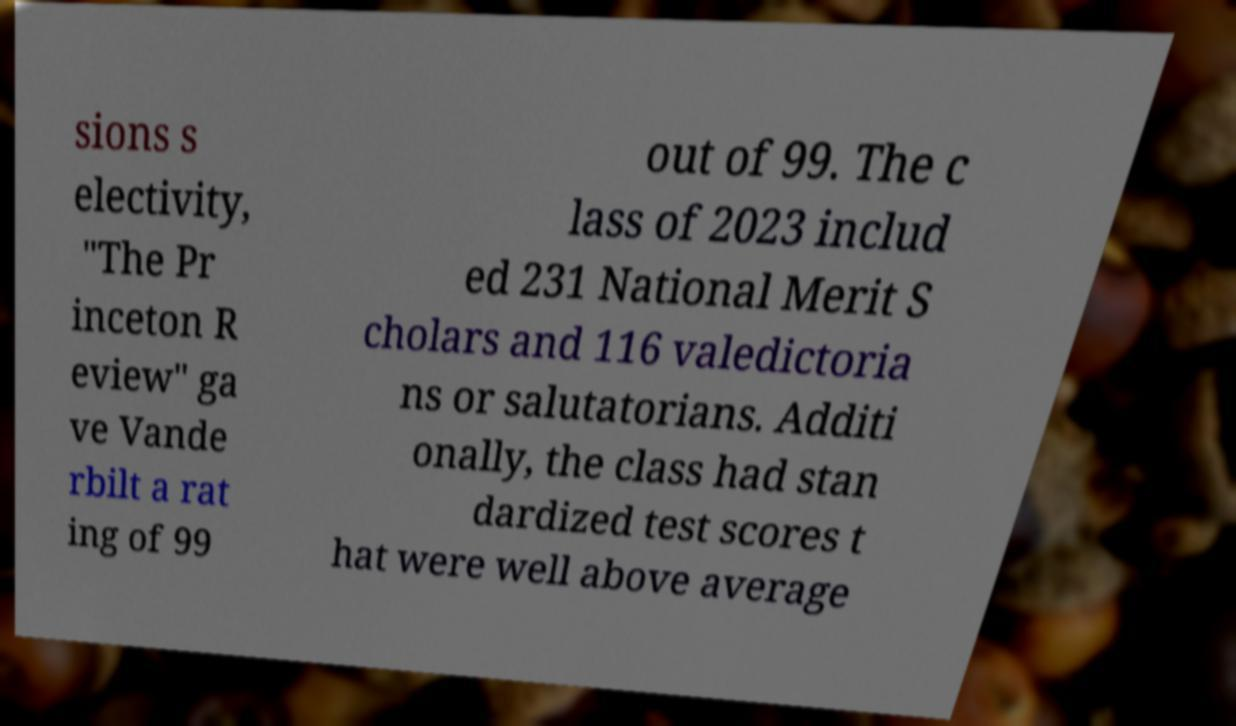I need the written content from this picture converted into text. Can you do that? sions s electivity, "The Pr inceton R eview" ga ve Vande rbilt a rat ing of 99 out of 99. The c lass of 2023 includ ed 231 National Merit S cholars and 116 valedictoria ns or salutatorians. Additi onally, the class had stan dardized test scores t hat were well above average 